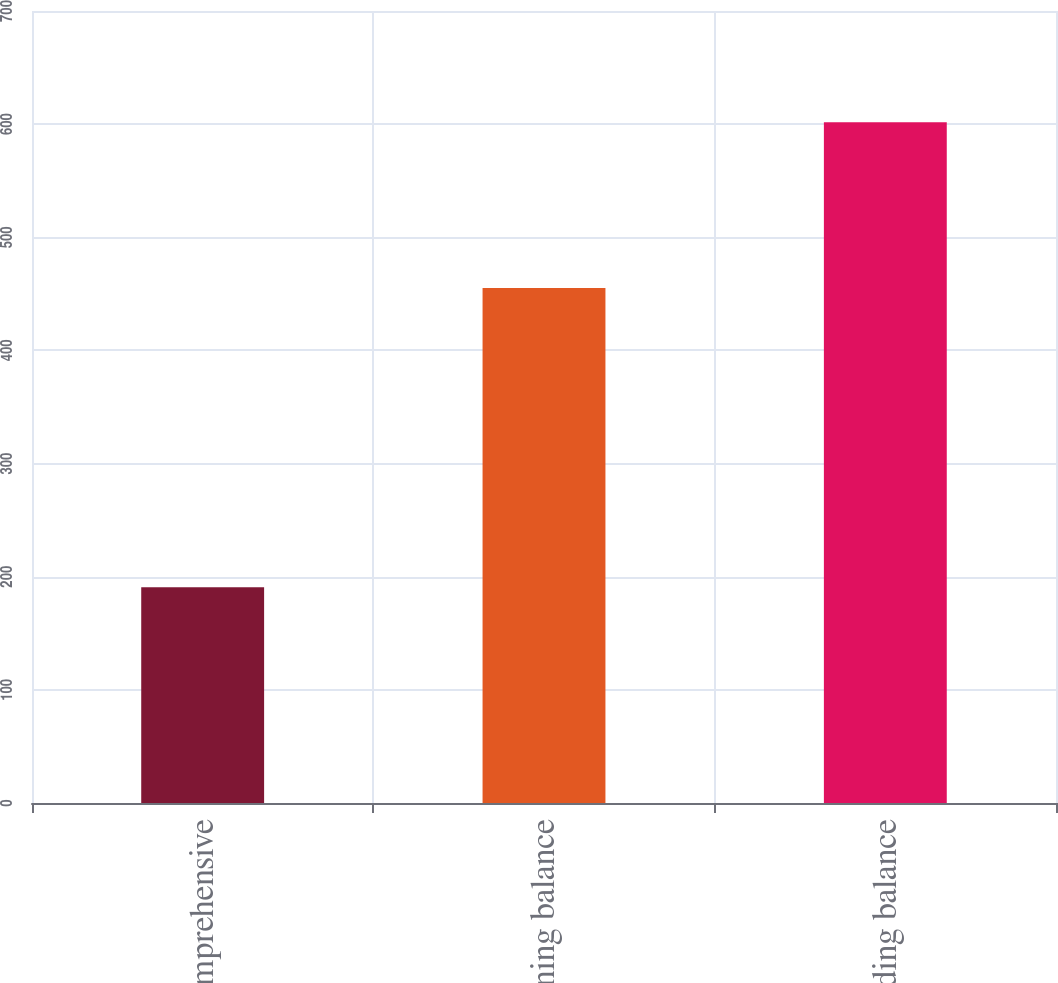<chart> <loc_0><loc_0><loc_500><loc_500><bar_chart><fcel>Other comprehensive<fcel>Beginning balance<fcel>Ending balance<nl><fcel>190.67<fcel>455.2<fcel>601.7<nl></chart> 